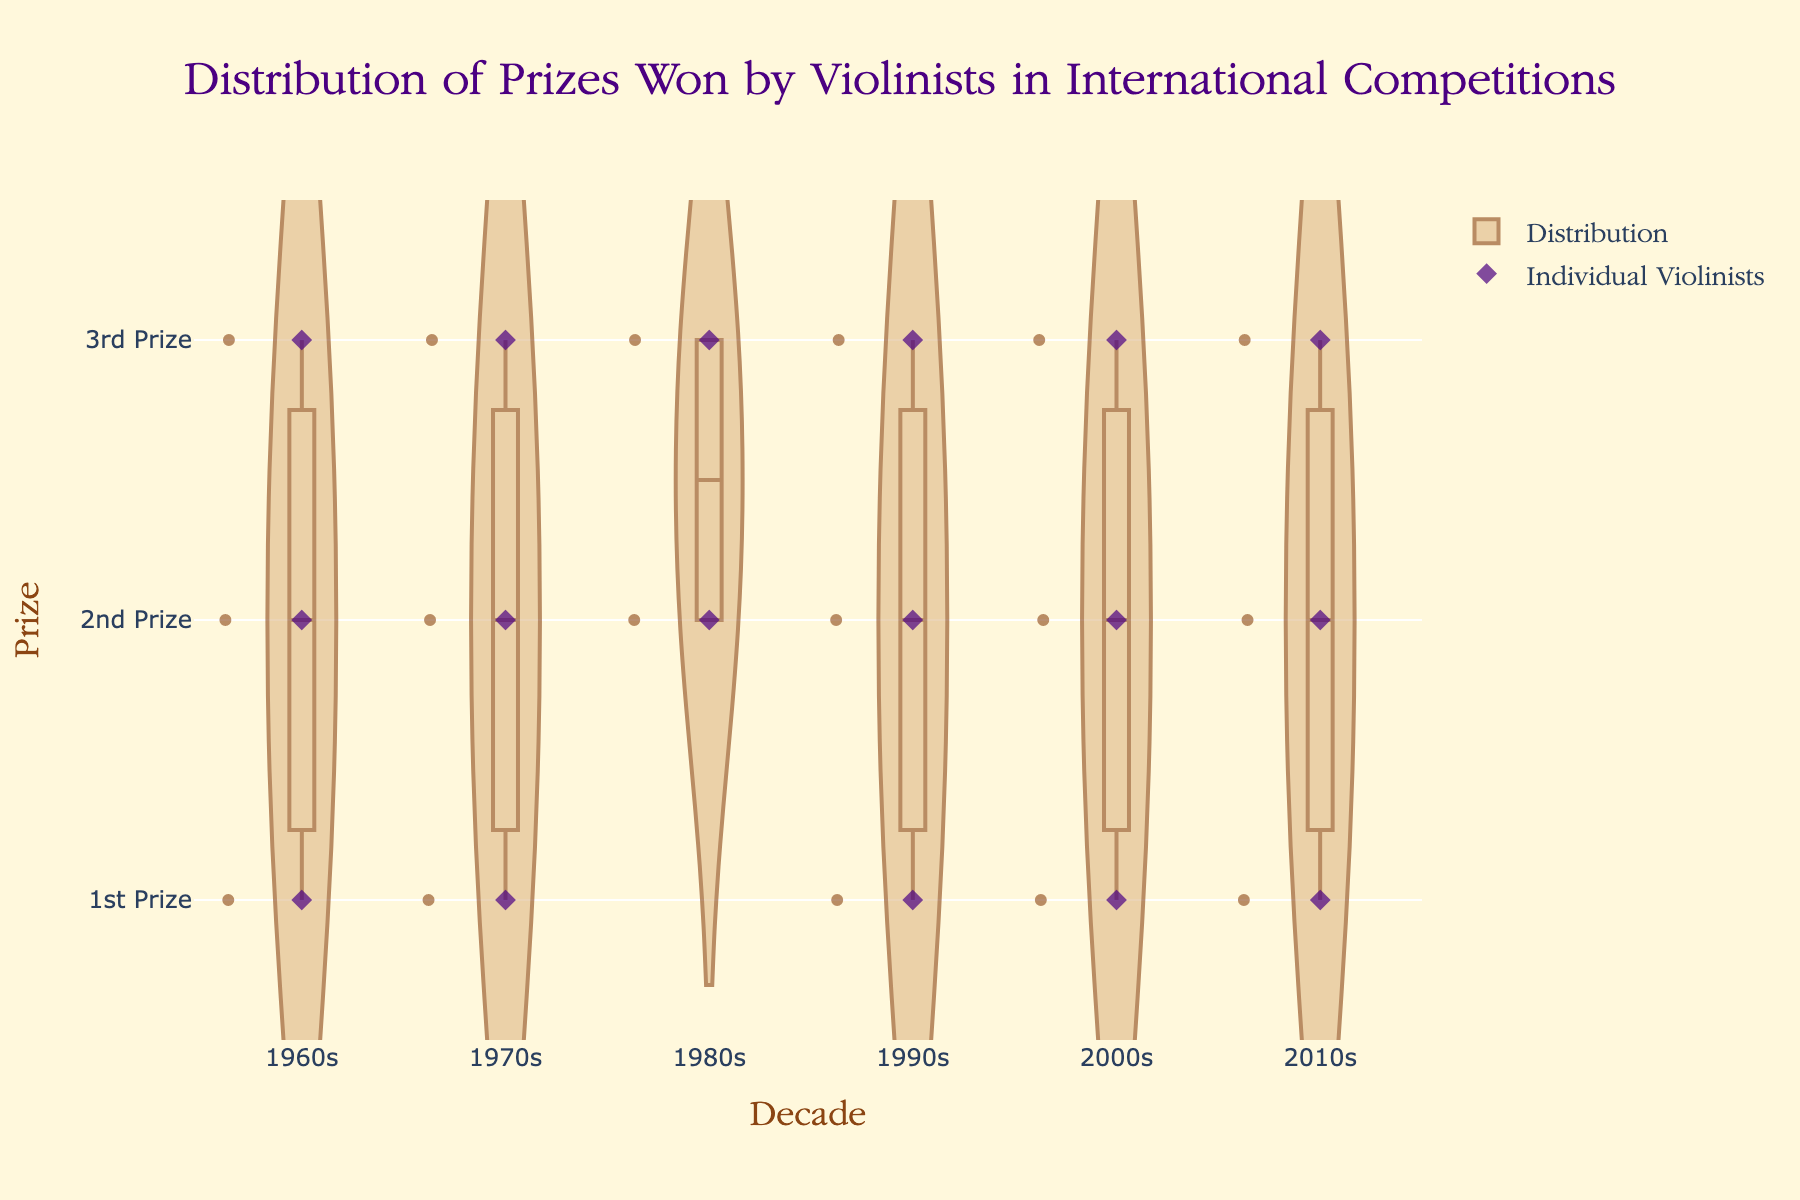What is the title of the figure? Look at the top of the figure to find the title. It should be prominently displayed.
Answer: Distribution of Prizes Won by Violinists in International Competitions What does the vertical axis represent in the figure? Observe the label and ticks on the vertical axis.
Answer: Prize Which decade shows the most entries for prizes? Count the number of violinist entries (jittered points) for each decade.
Answer: 1980s Which violinist won a 1st prize in the 1960s? Look at the points for the 1960s on the vertical axis where the prize is 1st Prize, and check the hover information.
Answer: David Oistrakh How many violinists won a 2nd prize in the 1990s? Find the points for the 1990s on the vertical axis where the prize is 2nd Prize and count them.
Answer: 1 Are there any decades where no violinists won a 3rd prize? Examine each decade for points that fall into the 3rd Prize category to see if any decade lacks such data points.
Answer: No Compare the number of 1st Prize winners in the 1960s and 2010s. Which decade had more? Count the number of points for 1st Prize in both the 1960s and 2010s and compare.
Answer: 2010s What is the pattern of prize distribution from the 1960s to the 2010s? Observe the arrangement of points and the violin plot's shape across each decade to identify trends.
Answer: Varied distribution with similar spread across decades How does the number of points for 1st Prize compare to the number of points for 2nd Prize across all decades? Count the total number of points for 1st Prize and 2nd Prize across all decades and compare.
Answer: Equal (5 each) Which specific competitions are represented more than once in the figure? Identify the competition names listed for more than one point across all decades.
Answer: None 